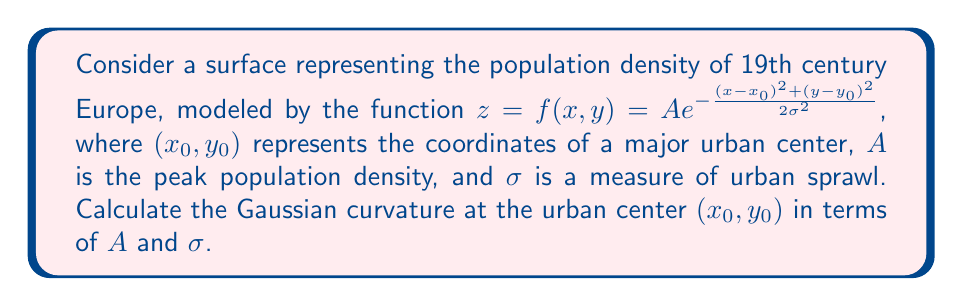Solve this math problem. To calculate the Gaussian curvature, we need to follow these steps:

1) The Gaussian curvature K is given by:
   $$K = \frac{f_{xx}f_{yy} - f_{xy}^2}{(1+f_x^2+f_y^2)^2}$$
   where subscripts denote partial derivatives.

2) Let's calculate the partial derivatives:
   $$f_x = -\frac{A(x-x_0)}{\sigma^2}e^{-\frac{(x-x_0)^2+(y-y_0)^2}{2\sigma^2}}$$
   $$f_y = -\frac{A(y-y_0)}{\sigma^2}e^{-\frac{(x-x_0)^2+(y-y_0)^2}{2\sigma^2}}$$

3) Second partial derivatives:
   $$f_{xx} = \frac{A}{\sigma^4}\left((x-x_0)^2-\sigma^2\right)e^{-\frac{(x-x_0)^2+(y-y_0)^2}{2\sigma^2}}$$
   $$f_{yy} = \frac{A}{\sigma^4}\left((y-y_0)^2-\sigma^2\right)e^{-\frac{(x-x_0)^2+(y-y_0)^2}{2\sigma^2}}$$
   $$f_{xy} = \frac{A(x-x_0)(y-y_0)}{\sigma^4}e^{-\frac{(x-x_0)^2+(y-y_0)^2}{2\sigma^2}}$$

4) At the urban center $(x_0,y_0)$:
   $$f_x = f_y = 0$$
   $$f_{xx} = f_{yy} = -\frac{A}{\sigma^2}$$
   $$f_{xy} = 0$$

5) Substituting these values into the Gaussian curvature formula:
   $$K = \frac{(-\frac{A}{\sigma^2})(-\frac{A}{\sigma^2}) - 0^2}{(1+0^2+0^2)^2} = \frac{A^2}{\sigma^4}$$

Thus, at the urban center, the Gaussian curvature is $\frac{A^2}{\sigma^4}$.
Answer: $\frac{A^2}{\sigma^4}$ 